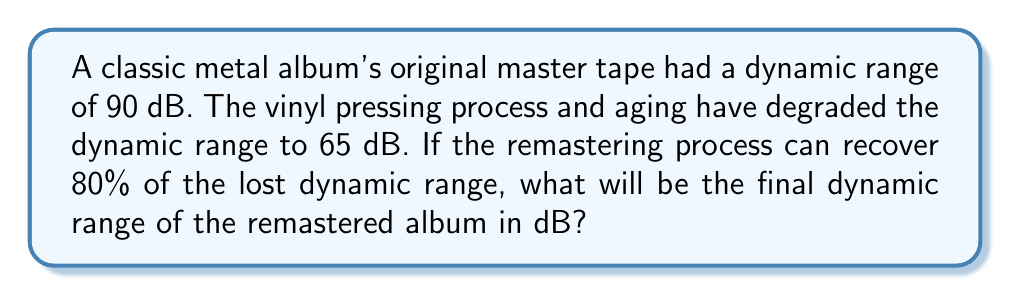Can you solve this math problem? Let's approach this step-by-step:

1) First, calculate the lost dynamic range:
   $$ \text{Lost range} = 90 \text{ dB} - 65 \text{ dB} = 25 \text{ dB} $$

2) The remastering process can recover 80% of this lost range:
   $$ \text{Recovered range} = 80\% \times 25 \text{ dB} = 0.8 \times 25 \text{ dB} = 20 \text{ dB} $$

3) To find the final dynamic range, add the recovered range to the degraded range:
   $$ \text{Final range} = 65 \text{ dB} + 20 \text{ dB} = 85 \text{ dB} $$

Therefore, the final dynamic range of the remastered album will be 85 dB.
Answer: 85 dB 